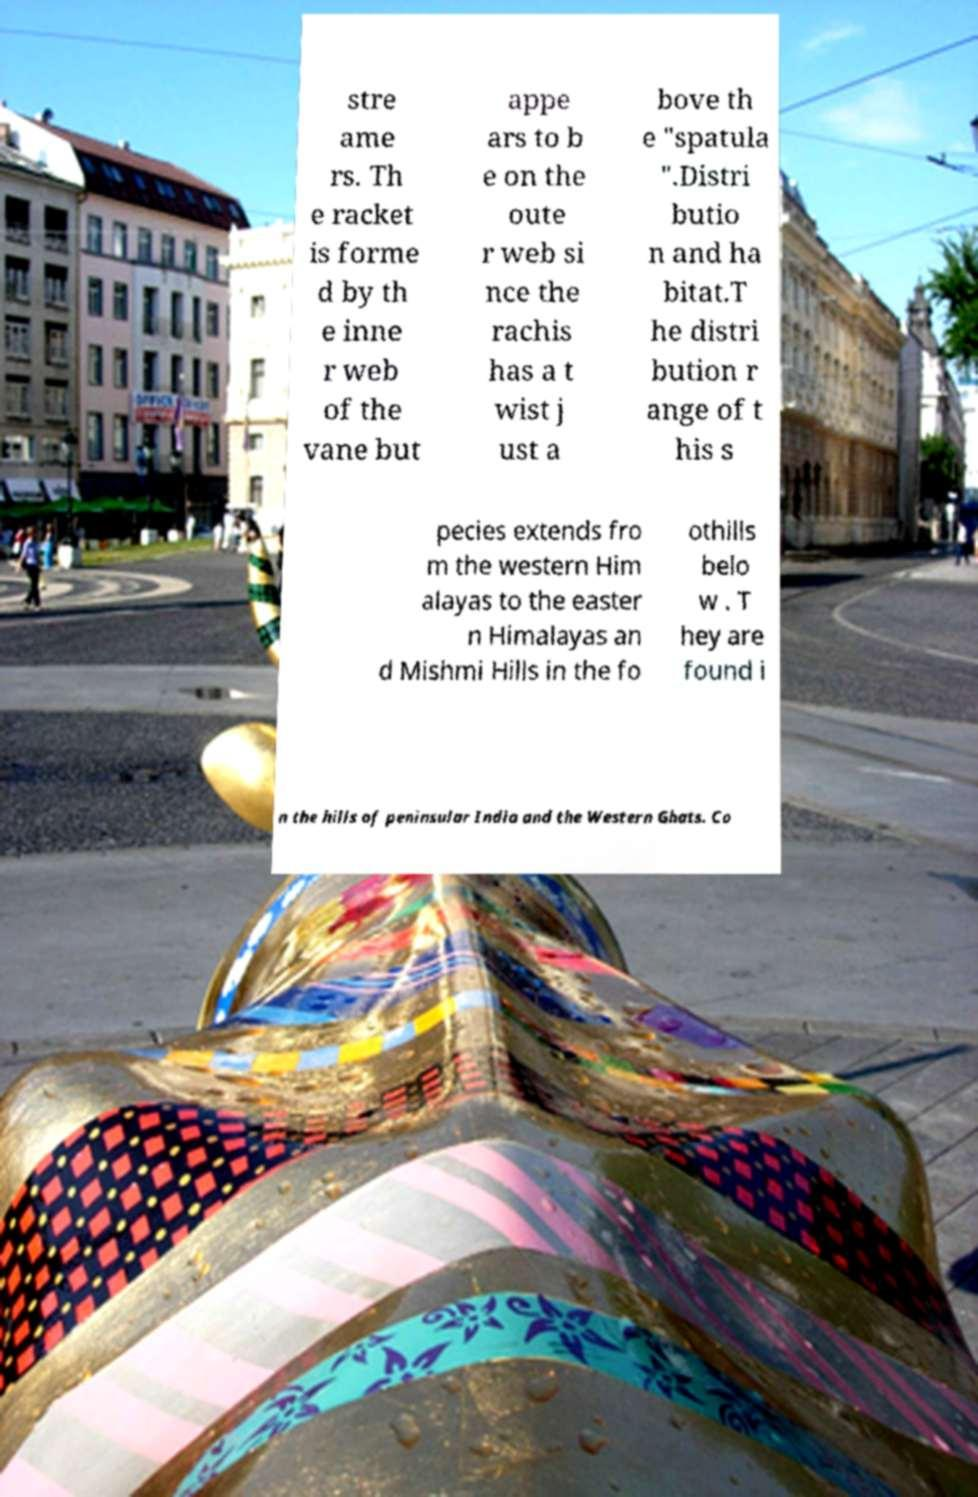Could you assist in decoding the text presented in this image and type it out clearly? stre ame rs. Th e racket is forme d by th e inne r web of the vane but appe ars to b e on the oute r web si nce the rachis has a t wist j ust a bove th e "spatula ".Distri butio n and ha bitat.T he distri bution r ange of t his s pecies extends fro m the western Him alayas to the easter n Himalayas an d Mishmi Hills in the fo othills belo w . T hey are found i n the hills of peninsular India and the Western Ghats. Co 